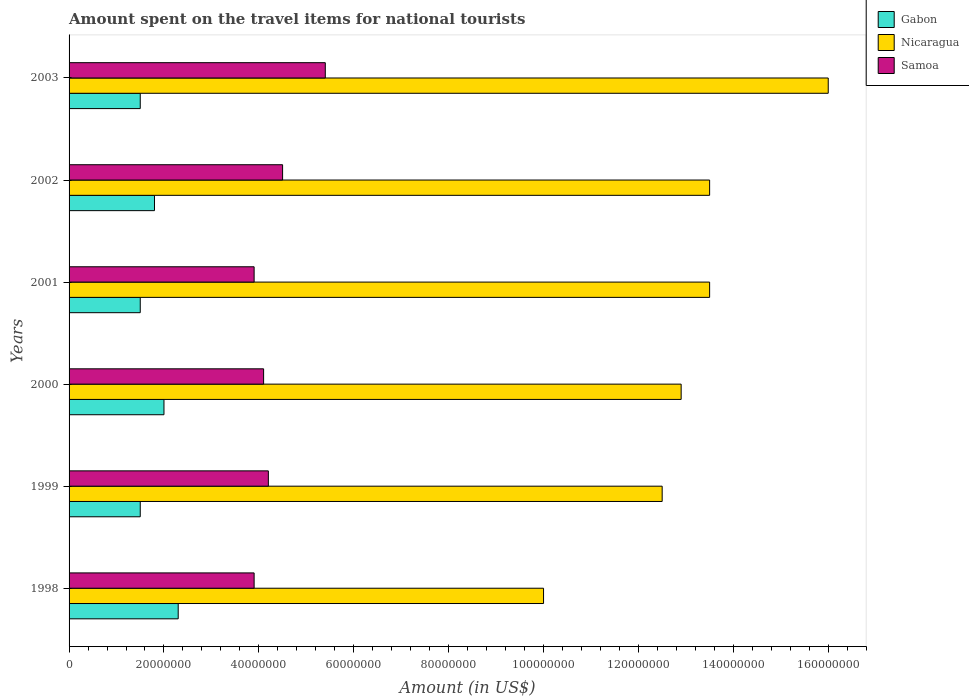Are the number of bars per tick equal to the number of legend labels?
Your answer should be very brief. Yes. Are the number of bars on each tick of the Y-axis equal?
Provide a succinct answer. Yes. How many bars are there on the 1st tick from the bottom?
Your answer should be very brief. 3. What is the label of the 2nd group of bars from the top?
Your answer should be compact. 2002. What is the amount spent on the travel items for national tourists in Gabon in 2001?
Ensure brevity in your answer.  1.50e+07. Across all years, what is the maximum amount spent on the travel items for national tourists in Nicaragua?
Ensure brevity in your answer.  1.60e+08. Across all years, what is the minimum amount spent on the travel items for national tourists in Gabon?
Your response must be concise. 1.50e+07. What is the total amount spent on the travel items for national tourists in Nicaragua in the graph?
Offer a very short reply. 7.84e+08. What is the difference between the amount spent on the travel items for national tourists in Nicaragua in 2001 and that in 2002?
Keep it short and to the point. 0. What is the difference between the amount spent on the travel items for national tourists in Gabon in 1998 and the amount spent on the travel items for national tourists in Nicaragua in 2001?
Keep it short and to the point. -1.12e+08. What is the average amount spent on the travel items for national tourists in Nicaragua per year?
Your answer should be very brief. 1.31e+08. In the year 2001, what is the difference between the amount spent on the travel items for national tourists in Gabon and amount spent on the travel items for national tourists in Samoa?
Your answer should be very brief. -2.40e+07. What is the ratio of the amount spent on the travel items for national tourists in Nicaragua in 1998 to that in 2003?
Offer a terse response. 0.62. Is the difference between the amount spent on the travel items for national tourists in Gabon in 1999 and 2003 greater than the difference between the amount spent on the travel items for national tourists in Samoa in 1999 and 2003?
Make the answer very short. Yes. What is the difference between the highest and the second highest amount spent on the travel items for national tourists in Samoa?
Offer a very short reply. 9.00e+06. What is the difference between the highest and the lowest amount spent on the travel items for national tourists in Gabon?
Provide a succinct answer. 8.00e+06. Is the sum of the amount spent on the travel items for national tourists in Nicaragua in 1998 and 1999 greater than the maximum amount spent on the travel items for national tourists in Gabon across all years?
Offer a very short reply. Yes. What does the 2nd bar from the top in 1998 represents?
Provide a succinct answer. Nicaragua. What does the 1st bar from the bottom in 2003 represents?
Provide a succinct answer. Gabon. Is it the case that in every year, the sum of the amount spent on the travel items for national tourists in Samoa and amount spent on the travel items for national tourists in Nicaragua is greater than the amount spent on the travel items for national tourists in Gabon?
Offer a very short reply. Yes. Are all the bars in the graph horizontal?
Give a very brief answer. Yes. How many years are there in the graph?
Give a very brief answer. 6. Does the graph contain any zero values?
Offer a very short reply. No. Where does the legend appear in the graph?
Make the answer very short. Top right. What is the title of the graph?
Your response must be concise. Amount spent on the travel items for national tourists. Does "Sudan" appear as one of the legend labels in the graph?
Keep it short and to the point. No. What is the label or title of the X-axis?
Keep it short and to the point. Amount (in US$). What is the Amount (in US$) in Gabon in 1998?
Your response must be concise. 2.30e+07. What is the Amount (in US$) in Samoa in 1998?
Make the answer very short. 3.90e+07. What is the Amount (in US$) in Gabon in 1999?
Offer a terse response. 1.50e+07. What is the Amount (in US$) in Nicaragua in 1999?
Your answer should be very brief. 1.25e+08. What is the Amount (in US$) of Samoa in 1999?
Provide a succinct answer. 4.20e+07. What is the Amount (in US$) in Nicaragua in 2000?
Keep it short and to the point. 1.29e+08. What is the Amount (in US$) of Samoa in 2000?
Your answer should be very brief. 4.10e+07. What is the Amount (in US$) of Gabon in 2001?
Offer a very short reply. 1.50e+07. What is the Amount (in US$) in Nicaragua in 2001?
Ensure brevity in your answer.  1.35e+08. What is the Amount (in US$) of Samoa in 2001?
Your answer should be compact. 3.90e+07. What is the Amount (in US$) in Gabon in 2002?
Offer a terse response. 1.80e+07. What is the Amount (in US$) in Nicaragua in 2002?
Provide a short and direct response. 1.35e+08. What is the Amount (in US$) of Samoa in 2002?
Ensure brevity in your answer.  4.50e+07. What is the Amount (in US$) of Gabon in 2003?
Give a very brief answer. 1.50e+07. What is the Amount (in US$) of Nicaragua in 2003?
Keep it short and to the point. 1.60e+08. What is the Amount (in US$) in Samoa in 2003?
Your answer should be compact. 5.40e+07. Across all years, what is the maximum Amount (in US$) in Gabon?
Your answer should be compact. 2.30e+07. Across all years, what is the maximum Amount (in US$) in Nicaragua?
Offer a very short reply. 1.60e+08. Across all years, what is the maximum Amount (in US$) of Samoa?
Your answer should be compact. 5.40e+07. Across all years, what is the minimum Amount (in US$) in Gabon?
Provide a succinct answer. 1.50e+07. Across all years, what is the minimum Amount (in US$) of Nicaragua?
Your answer should be compact. 1.00e+08. Across all years, what is the minimum Amount (in US$) of Samoa?
Provide a short and direct response. 3.90e+07. What is the total Amount (in US$) in Gabon in the graph?
Offer a very short reply. 1.06e+08. What is the total Amount (in US$) in Nicaragua in the graph?
Your answer should be very brief. 7.84e+08. What is the total Amount (in US$) in Samoa in the graph?
Your answer should be compact. 2.60e+08. What is the difference between the Amount (in US$) in Gabon in 1998 and that in 1999?
Provide a short and direct response. 8.00e+06. What is the difference between the Amount (in US$) of Nicaragua in 1998 and that in 1999?
Give a very brief answer. -2.50e+07. What is the difference between the Amount (in US$) in Nicaragua in 1998 and that in 2000?
Make the answer very short. -2.90e+07. What is the difference between the Amount (in US$) of Samoa in 1998 and that in 2000?
Your response must be concise. -2.00e+06. What is the difference between the Amount (in US$) of Nicaragua in 1998 and that in 2001?
Provide a succinct answer. -3.50e+07. What is the difference between the Amount (in US$) of Gabon in 1998 and that in 2002?
Your answer should be compact. 5.00e+06. What is the difference between the Amount (in US$) in Nicaragua in 1998 and that in 2002?
Your response must be concise. -3.50e+07. What is the difference between the Amount (in US$) of Samoa in 1998 and that in 2002?
Offer a very short reply. -6.00e+06. What is the difference between the Amount (in US$) in Gabon in 1998 and that in 2003?
Your answer should be compact. 8.00e+06. What is the difference between the Amount (in US$) in Nicaragua in 1998 and that in 2003?
Give a very brief answer. -6.00e+07. What is the difference between the Amount (in US$) in Samoa in 1998 and that in 2003?
Make the answer very short. -1.50e+07. What is the difference between the Amount (in US$) of Gabon in 1999 and that in 2000?
Offer a terse response. -5.00e+06. What is the difference between the Amount (in US$) of Gabon in 1999 and that in 2001?
Your response must be concise. 0. What is the difference between the Amount (in US$) in Nicaragua in 1999 and that in 2001?
Keep it short and to the point. -1.00e+07. What is the difference between the Amount (in US$) of Nicaragua in 1999 and that in 2002?
Your response must be concise. -1.00e+07. What is the difference between the Amount (in US$) of Samoa in 1999 and that in 2002?
Your response must be concise. -3.00e+06. What is the difference between the Amount (in US$) in Gabon in 1999 and that in 2003?
Give a very brief answer. 0. What is the difference between the Amount (in US$) of Nicaragua in 1999 and that in 2003?
Offer a terse response. -3.50e+07. What is the difference between the Amount (in US$) of Samoa in 1999 and that in 2003?
Offer a terse response. -1.20e+07. What is the difference between the Amount (in US$) in Gabon in 2000 and that in 2001?
Provide a succinct answer. 5.00e+06. What is the difference between the Amount (in US$) in Nicaragua in 2000 and that in 2001?
Provide a succinct answer. -6.00e+06. What is the difference between the Amount (in US$) of Nicaragua in 2000 and that in 2002?
Give a very brief answer. -6.00e+06. What is the difference between the Amount (in US$) in Samoa in 2000 and that in 2002?
Ensure brevity in your answer.  -4.00e+06. What is the difference between the Amount (in US$) of Gabon in 2000 and that in 2003?
Keep it short and to the point. 5.00e+06. What is the difference between the Amount (in US$) of Nicaragua in 2000 and that in 2003?
Keep it short and to the point. -3.10e+07. What is the difference between the Amount (in US$) in Samoa in 2000 and that in 2003?
Keep it short and to the point. -1.30e+07. What is the difference between the Amount (in US$) in Nicaragua in 2001 and that in 2002?
Offer a terse response. 0. What is the difference between the Amount (in US$) in Samoa in 2001 and that in 2002?
Provide a succinct answer. -6.00e+06. What is the difference between the Amount (in US$) of Nicaragua in 2001 and that in 2003?
Ensure brevity in your answer.  -2.50e+07. What is the difference between the Amount (in US$) in Samoa in 2001 and that in 2003?
Provide a succinct answer. -1.50e+07. What is the difference between the Amount (in US$) of Gabon in 2002 and that in 2003?
Your answer should be compact. 3.00e+06. What is the difference between the Amount (in US$) of Nicaragua in 2002 and that in 2003?
Provide a short and direct response. -2.50e+07. What is the difference between the Amount (in US$) of Samoa in 2002 and that in 2003?
Your answer should be compact. -9.00e+06. What is the difference between the Amount (in US$) of Gabon in 1998 and the Amount (in US$) of Nicaragua in 1999?
Keep it short and to the point. -1.02e+08. What is the difference between the Amount (in US$) of Gabon in 1998 and the Amount (in US$) of Samoa in 1999?
Provide a succinct answer. -1.90e+07. What is the difference between the Amount (in US$) in Nicaragua in 1998 and the Amount (in US$) in Samoa in 1999?
Your answer should be very brief. 5.80e+07. What is the difference between the Amount (in US$) of Gabon in 1998 and the Amount (in US$) of Nicaragua in 2000?
Ensure brevity in your answer.  -1.06e+08. What is the difference between the Amount (in US$) of Gabon in 1998 and the Amount (in US$) of Samoa in 2000?
Your answer should be compact. -1.80e+07. What is the difference between the Amount (in US$) in Nicaragua in 1998 and the Amount (in US$) in Samoa in 2000?
Your answer should be compact. 5.90e+07. What is the difference between the Amount (in US$) of Gabon in 1998 and the Amount (in US$) of Nicaragua in 2001?
Give a very brief answer. -1.12e+08. What is the difference between the Amount (in US$) in Gabon in 1998 and the Amount (in US$) in Samoa in 2001?
Your response must be concise. -1.60e+07. What is the difference between the Amount (in US$) of Nicaragua in 1998 and the Amount (in US$) of Samoa in 2001?
Your response must be concise. 6.10e+07. What is the difference between the Amount (in US$) in Gabon in 1998 and the Amount (in US$) in Nicaragua in 2002?
Ensure brevity in your answer.  -1.12e+08. What is the difference between the Amount (in US$) of Gabon in 1998 and the Amount (in US$) of Samoa in 2002?
Give a very brief answer. -2.20e+07. What is the difference between the Amount (in US$) of Nicaragua in 1998 and the Amount (in US$) of Samoa in 2002?
Give a very brief answer. 5.50e+07. What is the difference between the Amount (in US$) in Gabon in 1998 and the Amount (in US$) in Nicaragua in 2003?
Your answer should be compact. -1.37e+08. What is the difference between the Amount (in US$) in Gabon in 1998 and the Amount (in US$) in Samoa in 2003?
Your response must be concise. -3.10e+07. What is the difference between the Amount (in US$) of Nicaragua in 1998 and the Amount (in US$) of Samoa in 2003?
Keep it short and to the point. 4.60e+07. What is the difference between the Amount (in US$) of Gabon in 1999 and the Amount (in US$) of Nicaragua in 2000?
Give a very brief answer. -1.14e+08. What is the difference between the Amount (in US$) of Gabon in 1999 and the Amount (in US$) of Samoa in 2000?
Your answer should be very brief. -2.60e+07. What is the difference between the Amount (in US$) of Nicaragua in 1999 and the Amount (in US$) of Samoa in 2000?
Provide a short and direct response. 8.40e+07. What is the difference between the Amount (in US$) in Gabon in 1999 and the Amount (in US$) in Nicaragua in 2001?
Ensure brevity in your answer.  -1.20e+08. What is the difference between the Amount (in US$) of Gabon in 1999 and the Amount (in US$) of Samoa in 2001?
Provide a short and direct response. -2.40e+07. What is the difference between the Amount (in US$) of Nicaragua in 1999 and the Amount (in US$) of Samoa in 2001?
Offer a terse response. 8.60e+07. What is the difference between the Amount (in US$) of Gabon in 1999 and the Amount (in US$) of Nicaragua in 2002?
Give a very brief answer. -1.20e+08. What is the difference between the Amount (in US$) of Gabon in 1999 and the Amount (in US$) of Samoa in 2002?
Your answer should be very brief. -3.00e+07. What is the difference between the Amount (in US$) of Nicaragua in 1999 and the Amount (in US$) of Samoa in 2002?
Keep it short and to the point. 8.00e+07. What is the difference between the Amount (in US$) of Gabon in 1999 and the Amount (in US$) of Nicaragua in 2003?
Ensure brevity in your answer.  -1.45e+08. What is the difference between the Amount (in US$) of Gabon in 1999 and the Amount (in US$) of Samoa in 2003?
Ensure brevity in your answer.  -3.90e+07. What is the difference between the Amount (in US$) of Nicaragua in 1999 and the Amount (in US$) of Samoa in 2003?
Offer a terse response. 7.10e+07. What is the difference between the Amount (in US$) in Gabon in 2000 and the Amount (in US$) in Nicaragua in 2001?
Your response must be concise. -1.15e+08. What is the difference between the Amount (in US$) of Gabon in 2000 and the Amount (in US$) of Samoa in 2001?
Your answer should be compact. -1.90e+07. What is the difference between the Amount (in US$) in Nicaragua in 2000 and the Amount (in US$) in Samoa in 2001?
Provide a short and direct response. 9.00e+07. What is the difference between the Amount (in US$) in Gabon in 2000 and the Amount (in US$) in Nicaragua in 2002?
Your answer should be compact. -1.15e+08. What is the difference between the Amount (in US$) in Gabon in 2000 and the Amount (in US$) in Samoa in 2002?
Offer a terse response. -2.50e+07. What is the difference between the Amount (in US$) in Nicaragua in 2000 and the Amount (in US$) in Samoa in 2002?
Give a very brief answer. 8.40e+07. What is the difference between the Amount (in US$) of Gabon in 2000 and the Amount (in US$) of Nicaragua in 2003?
Provide a short and direct response. -1.40e+08. What is the difference between the Amount (in US$) of Gabon in 2000 and the Amount (in US$) of Samoa in 2003?
Make the answer very short. -3.40e+07. What is the difference between the Amount (in US$) of Nicaragua in 2000 and the Amount (in US$) of Samoa in 2003?
Your answer should be very brief. 7.50e+07. What is the difference between the Amount (in US$) in Gabon in 2001 and the Amount (in US$) in Nicaragua in 2002?
Offer a very short reply. -1.20e+08. What is the difference between the Amount (in US$) of Gabon in 2001 and the Amount (in US$) of Samoa in 2002?
Provide a short and direct response. -3.00e+07. What is the difference between the Amount (in US$) of Nicaragua in 2001 and the Amount (in US$) of Samoa in 2002?
Give a very brief answer. 9.00e+07. What is the difference between the Amount (in US$) in Gabon in 2001 and the Amount (in US$) in Nicaragua in 2003?
Ensure brevity in your answer.  -1.45e+08. What is the difference between the Amount (in US$) of Gabon in 2001 and the Amount (in US$) of Samoa in 2003?
Provide a short and direct response. -3.90e+07. What is the difference between the Amount (in US$) in Nicaragua in 2001 and the Amount (in US$) in Samoa in 2003?
Offer a very short reply. 8.10e+07. What is the difference between the Amount (in US$) in Gabon in 2002 and the Amount (in US$) in Nicaragua in 2003?
Your response must be concise. -1.42e+08. What is the difference between the Amount (in US$) of Gabon in 2002 and the Amount (in US$) of Samoa in 2003?
Keep it short and to the point. -3.60e+07. What is the difference between the Amount (in US$) in Nicaragua in 2002 and the Amount (in US$) in Samoa in 2003?
Your response must be concise. 8.10e+07. What is the average Amount (in US$) in Gabon per year?
Keep it short and to the point. 1.77e+07. What is the average Amount (in US$) in Nicaragua per year?
Provide a succinct answer. 1.31e+08. What is the average Amount (in US$) in Samoa per year?
Ensure brevity in your answer.  4.33e+07. In the year 1998, what is the difference between the Amount (in US$) in Gabon and Amount (in US$) in Nicaragua?
Offer a terse response. -7.70e+07. In the year 1998, what is the difference between the Amount (in US$) of Gabon and Amount (in US$) of Samoa?
Your response must be concise. -1.60e+07. In the year 1998, what is the difference between the Amount (in US$) in Nicaragua and Amount (in US$) in Samoa?
Your response must be concise. 6.10e+07. In the year 1999, what is the difference between the Amount (in US$) in Gabon and Amount (in US$) in Nicaragua?
Your response must be concise. -1.10e+08. In the year 1999, what is the difference between the Amount (in US$) of Gabon and Amount (in US$) of Samoa?
Provide a short and direct response. -2.70e+07. In the year 1999, what is the difference between the Amount (in US$) of Nicaragua and Amount (in US$) of Samoa?
Provide a short and direct response. 8.30e+07. In the year 2000, what is the difference between the Amount (in US$) of Gabon and Amount (in US$) of Nicaragua?
Your answer should be compact. -1.09e+08. In the year 2000, what is the difference between the Amount (in US$) of Gabon and Amount (in US$) of Samoa?
Offer a terse response. -2.10e+07. In the year 2000, what is the difference between the Amount (in US$) of Nicaragua and Amount (in US$) of Samoa?
Your answer should be compact. 8.80e+07. In the year 2001, what is the difference between the Amount (in US$) of Gabon and Amount (in US$) of Nicaragua?
Offer a very short reply. -1.20e+08. In the year 2001, what is the difference between the Amount (in US$) in Gabon and Amount (in US$) in Samoa?
Offer a very short reply. -2.40e+07. In the year 2001, what is the difference between the Amount (in US$) of Nicaragua and Amount (in US$) of Samoa?
Your answer should be compact. 9.60e+07. In the year 2002, what is the difference between the Amount (in US$) in Gabon and Amount (in US$) in Nicaragua?
Provide a succinct answer. -1.17e+08. In the year 2002, what is the difference between the Amount (in US$) of Gabon and Amount (in US$) of Samoa?
Offer a terse response. -2.70e+07. In the year 2002, what is the difference between the Amount (in US$) of Nicaragua and Amount (in US$) of Samoa?
Provide a short and direct response. 9.00e+07. In the year 2003, what is the difference between the Amount (in US$) in Gabon and Amount (in US$) in Nicaragua?
Offer a terse response. -1.45e+08. In the year 2003, what is the difference between the Amount (in US$) in Gabon and Amount (in US$) in Samoa?
Your answer should be compact. -3.90e+07. In the year 2003, what is the difference between the Amount (in US$) in Nicaragua and Amount (in US$) in Samoa?
Your answer should be compact. 1.06e+08. What is the ratio of the Amount (in US$) of Gabon in 1998 to that in 1999?
Provide a succinct answer. 1.53. What is the ratio of the Amount (in US$) of Samoa in 1998 to that in 1999?
Provide a succinct answer. 0.93. What is the ratio of the Amount (in US$) of Gabon in 1998 to that in 2000?
Provide a succinct answer. 1.15. What is the ratio of the Amount (in US$) in Nicaragua in 1998 to that in 2000?
Your answer should be compact. 0.78. What is the ratio of the Amount (in US$) in Samoa in 1998 to that in 2000?
Your answer should be very brief. 0.95. What is the ratio of the Amount (in US$) in Gabon in 1998 to that in 2001?
Your response must be concise. 1.53. What is the ratio of the Amount (in US$) in Nicaragua in 1998 to that in 2001?
Ensure brevity in your answer.  0.74. What is the ratio of the Amount (in US$) in Gabon in 1998 to that in 2002?
Your response must be concise. 1.28. What is the ratio of the Amount (in US$) of Nicaragua in 1998 to that in 2002?
Offer a very short reply. 0.74. What is the ratio of the Amount (in US$) in Samoa in 1998 to that in 2002?
Make the answer very short. 0.87. What is the ratio of the Amount (in US$) in Gabon in 1998 to that in 2003?
Your response must be concise. 1.53. What is the ratio of the Amount (in US$) of Samoa in 1998 to that in 2003?
Your answer should be compact. 0.72. What is the ratio of the Amount (in US$) of Samoa in 1999 to that in 2000?
Provide a succinct answer. 1.02. What is the ratio of the Amount (in US$) of Nicaragua in 1999 to that in 2001?
Ensure brevity in your answer.  0.93. What is the ratio of the Amount (in US$) in Gabon in 1999 to that in 2002?
Offer a terse response. 0.83. What is the ratio of the Amount (in US$) in Nicaragua in 1999 to that in 2002?
Offer a terse response. 0.93. What is the ratio of the Amount (in US$) of Gabon in 1999 to that in 2003?
Keep it short and to the point. 1. What is the ratio of the Amount (in US$) in Nicaragua in 1999 to that in 2003?
Make the answer very short. 0.78. What is the ratio of the Amount (in US$) in Nicaragua in 2000 to that in 2001?
Your answer should be very brief. 0.96. What is the ratio of the Amount (in US$) of Samoa in 2000 to that in 2001?
Provide a short and direct response. 1.05. What is the ratio of the Amount (in US$) of Gabon in 2000 to that in 2002?
Offer a terse response. 1.11. What is the ratio of the Amount (in US$) in Nicaragua in 2000 to that in 2002?
Provide a succinct answer. 0.96. What is the ratio of the Amount (in US$) in Samoa in 2000 to that in 2002?
Keep it short and to the point. 0.91. What is the ratio of the Amount (in US$) in Nicaragua in 2000 to that in 2003?
Ensure brevity in your answer.  0.81. What is the ratio of the Amount (in US$) in Samoa in 2000 to that in 2003?
Make the answer very short. 0.76. What is the ratio of the Amount (in US$) in Nicaragua in 2001 to that in 2002?
Keep it short and to the point. 1. What is the ratio of the Amount (in US$) in Samoa in 2001 to that in 2002?
Provide a short and direct response. 0.87. What is the ratio of the Amount (in US$) in Nicaragua in 2001 to that in 2003?
Keep it short and to the point. 0.84. What is the ratio of the Amount (in US$) in Samoa in 2001 to that in 2003?
Your answer should be compact. 0.72. What is the ratio of the Amount (in US$) in Nicaragua in 2002 to that in 2003?
Your answer should be very brief. 0.84. What is the ratio of the Amount (in US$) in Samoa in 2002 to that in 2003?
Make the answer very short. 0.83. What is the difference between the highest and the second highest Amount (in US$) of Nicaragua?
Ensure brevity in your answer.  2.50e+07. What is the difference between the highest and the second highest Amount (in US$) of Samoa?
Keep it short and to the point. 9.00e+06. What is the difference between the highest and the lowest Amount (in US$) in Nicaragua?
Keep it short and to the point. 6.00e+07. What is the difference between the highest and the lowest Amount (in US$) in Samoa?
Provide a short and direct response. 1.50e+07. 